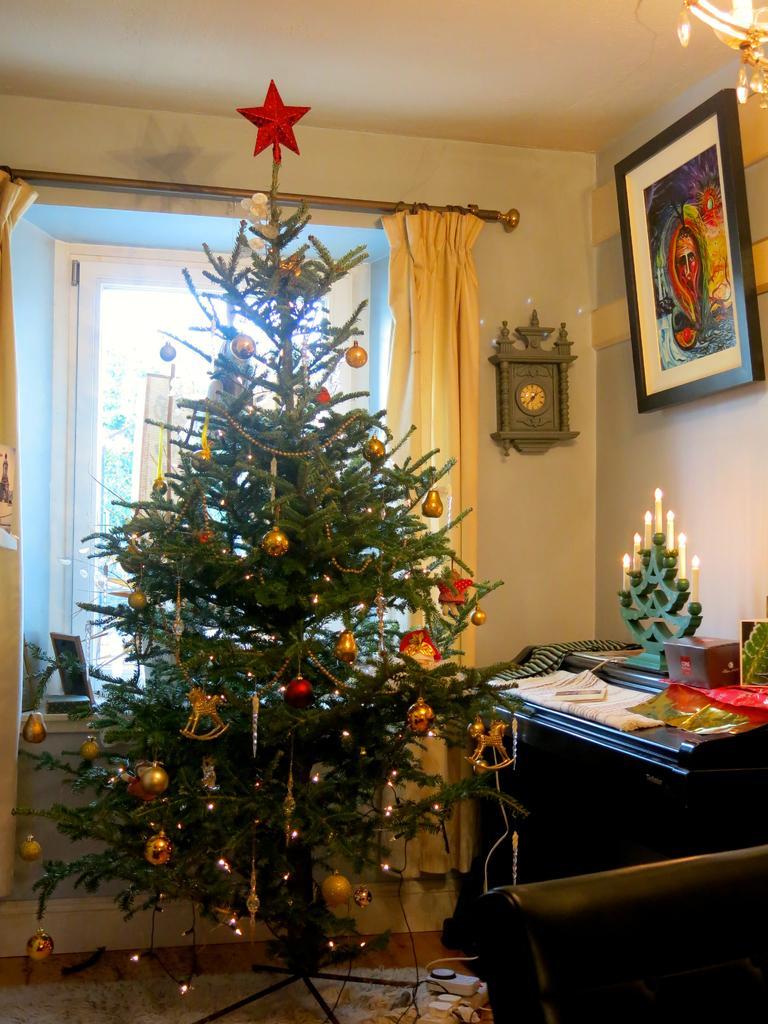Describe this image in one or two sentences. In this image I can see a Christmas tree and a clock, a frame on these walls. 